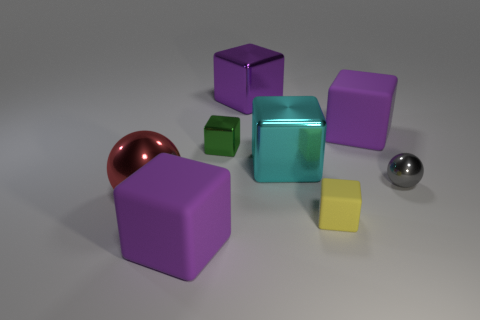Does the small rubber block have the same color as the small shiny ball?
Provide a succinct answer. No. What is the color of the other metallic object that is the same shape as the gray shiny object?
Give a very brief answer. Red. There is a metallic block that is the same size as the yellow thing; what is its color?
Provide a short and direct response. Green. Is there a rubber thing of the same color as the tiny rubber cube?
Provide a succinct answer. No. What is the big sphere made of?
Keep it short and to the point. Metal. What number of gray blocks are there?
Keep it short and to the point. 0. Is the color of the rubber block behind the red metal object the same as the small metallic thing to the right of the tiny green thing?
Your answer should be very brief. No. What number of other things are the same size as the yellow object?
Make the answer very short. 2. There is a rubber thing in front of the yellow cube; what color is it?
Your response must be concise. Purple. Are the ball to the right of the large shiny ball and the large cyan block made of the same material?
Provide a short and direct response. Yes. 